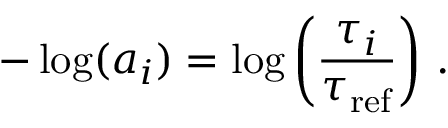Convert formula to latex. <formula><loc_0><loc_0><loc_500><loc_500>- \log ( a _ { i } ) = \log \left ( \frac { \tau _ { i } } { \tau _ { r e f } } \right ) \, .</formula> 